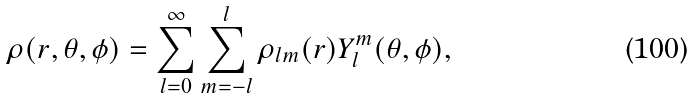<formula> <loc_0><loc_0><loc_500><loc_500>\rho ( r , \theta , \phi ) = \sum _ { l = 0 } ^ { \infty } \sum _ { m = - l } ^ { l } { \rho _ { l m } ( r ) Y _ { l } ^ { m } ( \theta , \phi ) } ,</formula> 